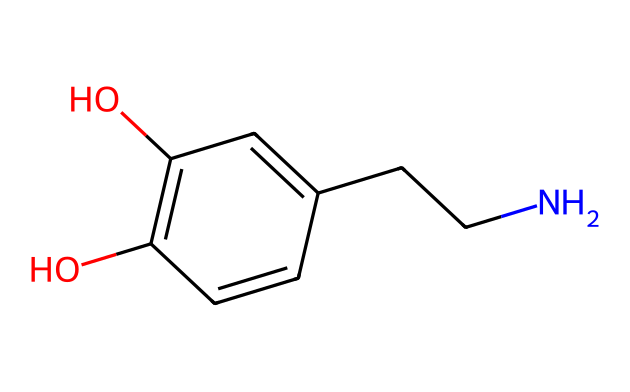What is the molecular formula of dopamine? The molecular formula can be derived from the atoms represented in the SMILES notation. By identifying individual atoms, we count 8 carbon (C) atoms, 11 hydrogen (H) atoms, 1 nitrogen (N) atom, and 3 oxygen (O) atoms, leading to the formula C8H11NO3.
Answer: C8H11NO3 How many hydroxyl (OH) groups are present in dopamine? By inspecting the structure represented in the SMILES, we observe that there are two -OH (hydroxyl) functional groups; each of them is indicated by the 'O' bonded to hydrogen (H).
Answer: 2 What is the role of the nitrogen atom in dopamine? The nitrogen atom in dopamine serves as part of the amine functional group, which is essential for its role as a neurotransmitter, facilitating communication between nerve cells.
Answer: neurotransmitter What is the total number of rings present in the dopamine structure? The SMILES notation contains a cyclic structure indicated by 'C1' and 'C=C(C=C1)', which shows that it contains one ring.
Answer: 1 How would the structure of dopamine change if one hydroxyl group was removed? Removal of one hydroxyl group would decrease its polarity and potentially affect its solubility and interaction with receptors, as hydroxyl groups contribute to hydrogen bonding.
Answer: decreased polarity Is dopamine classified as an aromatic compound? Yes, dopamine contains an aromatic ring as indicated by the alternating double bonds (C=C) and single bonds (C-C), which meets the criteria of aromaticity.
Answer: yes 